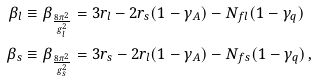Convert formula to latex. <formula><loc_0><loc_0><loc_500><loc_500>\beta _ { l } & \equiv \beta _ { \frac { 8 \pi ^ { 2 } } { g _ { l } ^ { 2 } } } = 3 r _ { l } - 2 r _ { s } ( 1 - \gamma _ { A } ) - N _ { f l } ( 1 - \gamma _ { q } ) \\ \beta _ { s } & \equiv \beta _ { \frac { 8 \pi ^ { 2 } } { g _ { s } ^ { 2 } } } = 3 r _ { s } - 2 r _ { l } ( 1 - \gamma _ { A } ) - N _ { f s } ( 1 - \gamma _ { q } ) \, ,</formula> 